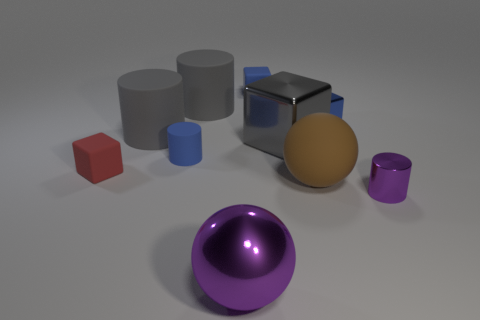Subtract all blue cylinders. How many cylinders are left? 3 Subtract 1 cylinders. How many cylinders are left? 3 Subtract all shiny cylinders. How many cylinders are left? 3 Subtract all green cubes. Subtract all cyan spheres. How many cubes are left? 4 Subtract all blocks. How many objects are left? 6 Add 1 red rubber spheres. How many red rubber spheres exist? 1 Subtract 0 cyan balls. How many objects are left? 10 Subtract all gray metallic cubes. Subtract all small objects. How many objects are left? 4 Add 9 small purple metallic cylinders. How many small purple metallic cylinders are left? 10 